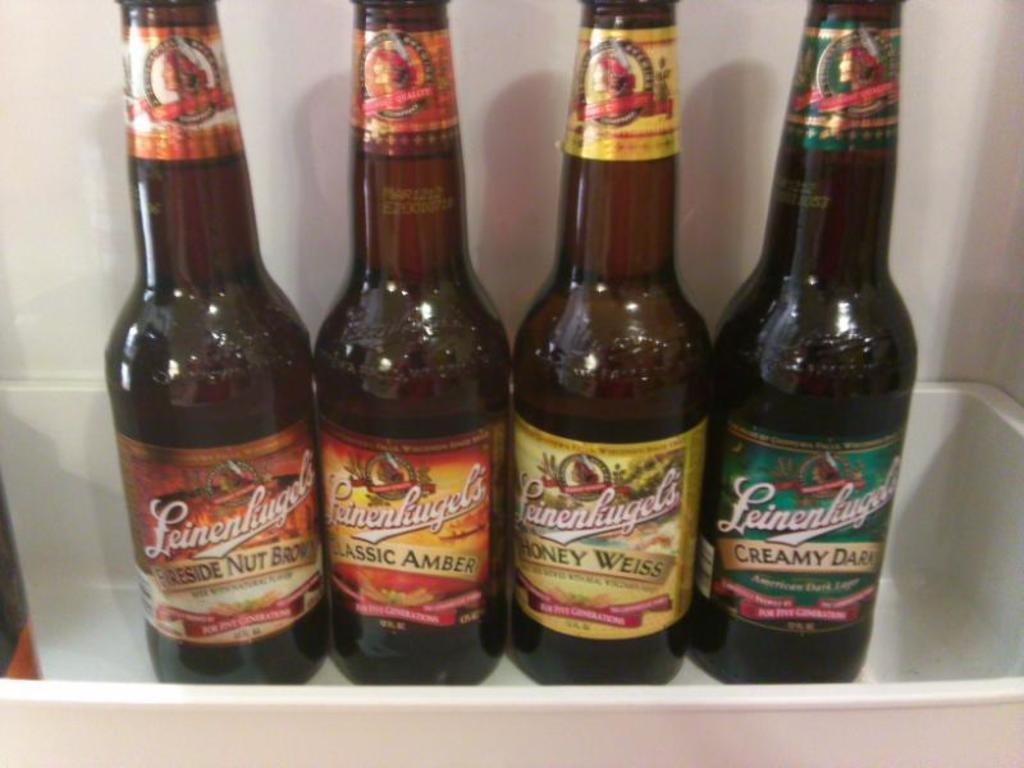Provide a one-sentence caption for the provided image. the word creamy is on one of the beer bottles. 